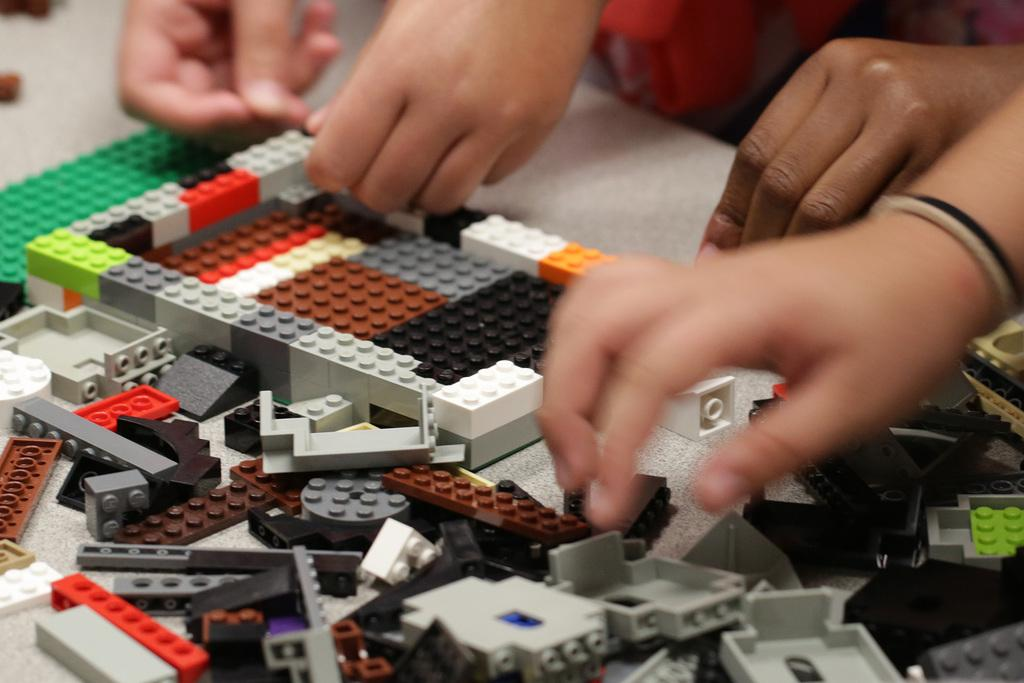What objects are on the table in the image? There are many building blocks on a table in the image. What are the kids doing with the building blocks? A few kids are holding building blocks in their hands in the image. What type of notebook is the child using to write down their vacation plans in the image? There is no notebook or mention of vacation plans in the image; it features building blocks and kids holding them. 